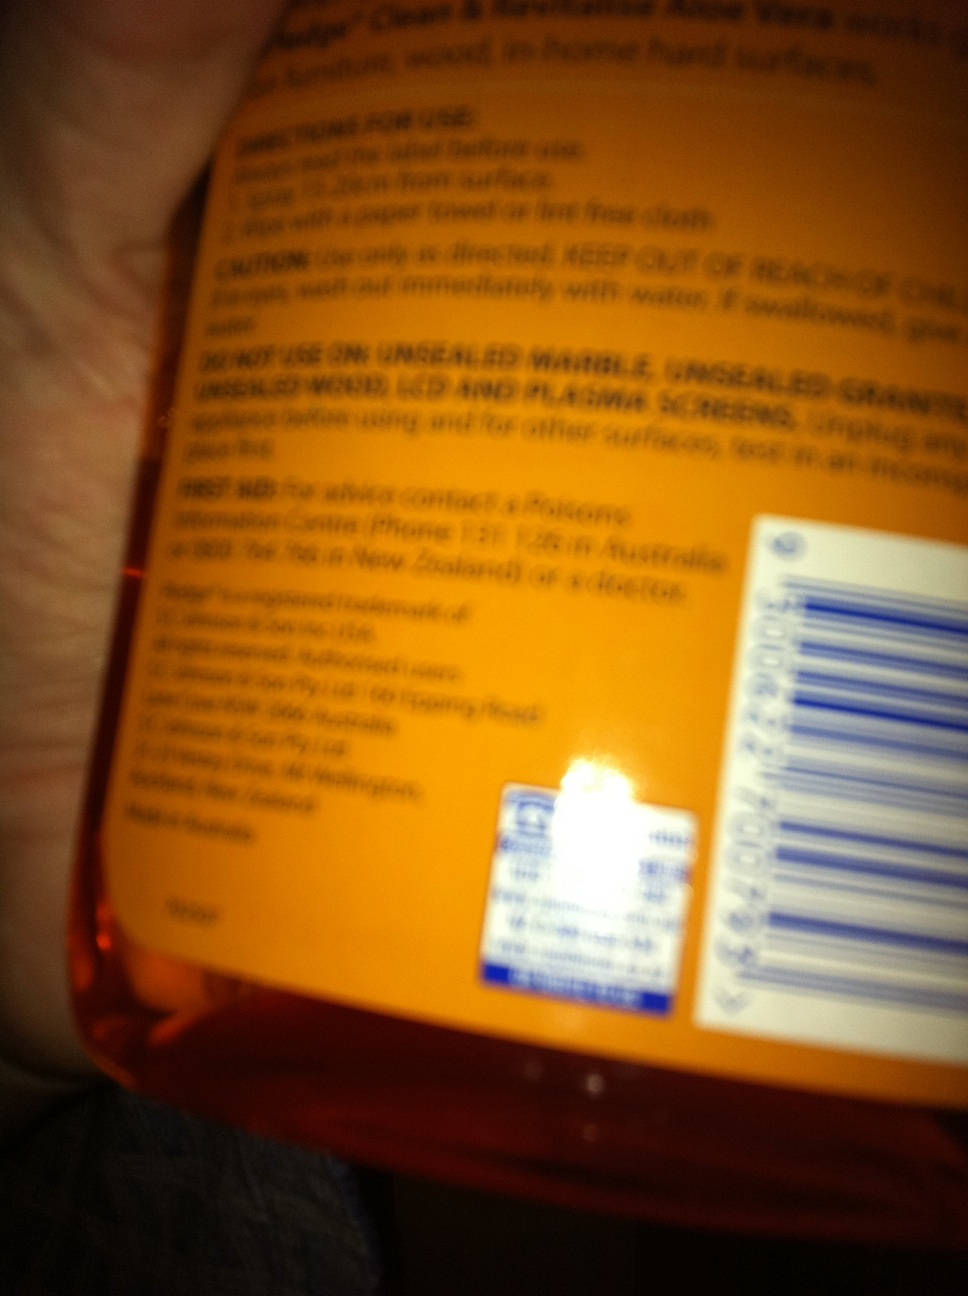What is in this bottle? The bottle contains a multi-purpose cleaner or a similar household product, as indicated by the warnings and instructions on the label, which mention to avoid use on certain surfaces and to rinse immediately with water if swallowed. 